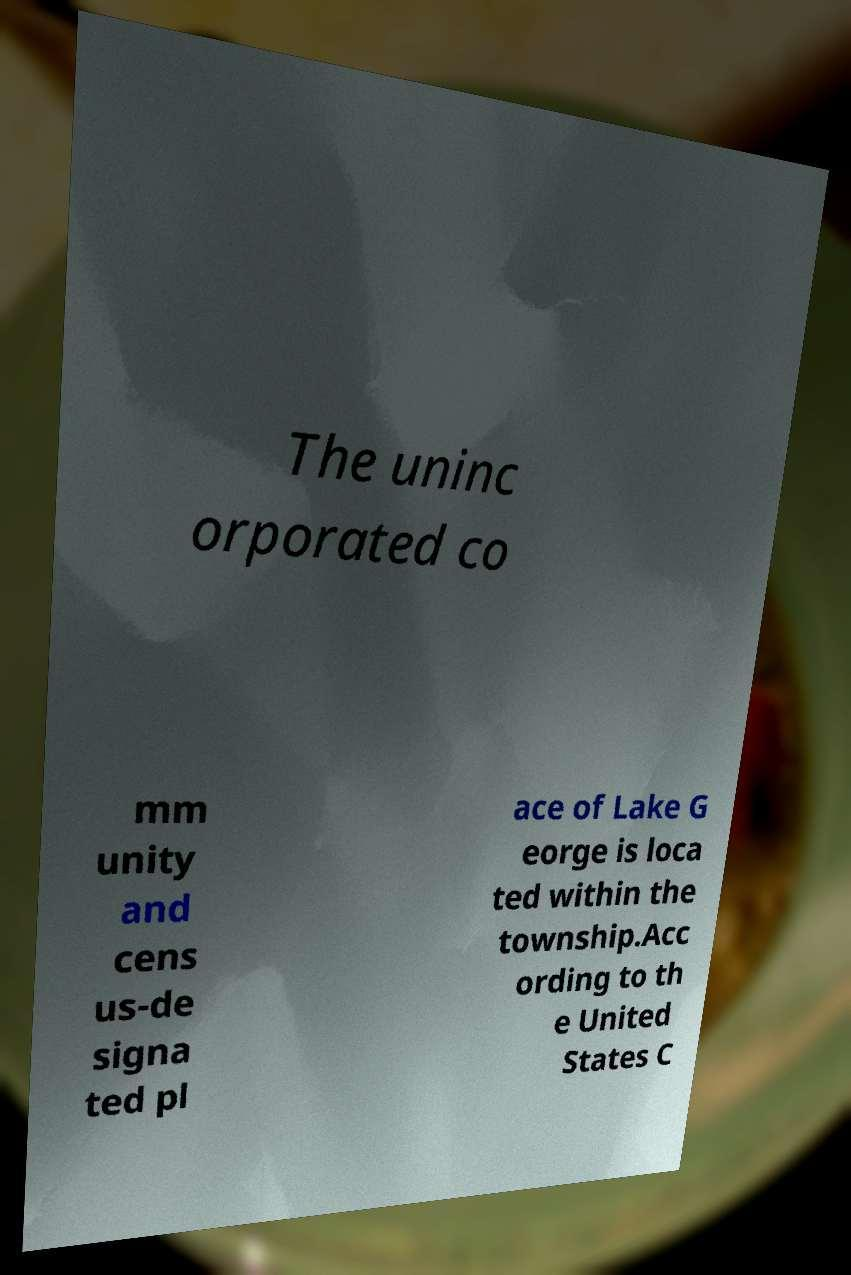I need the written content from this picture converted into text. Can you do that? The uninc orporated co mm unity and cens us-de signa ted pl ace of Lake G eorge is loca ted within the township.Acc ording to th e United States C 